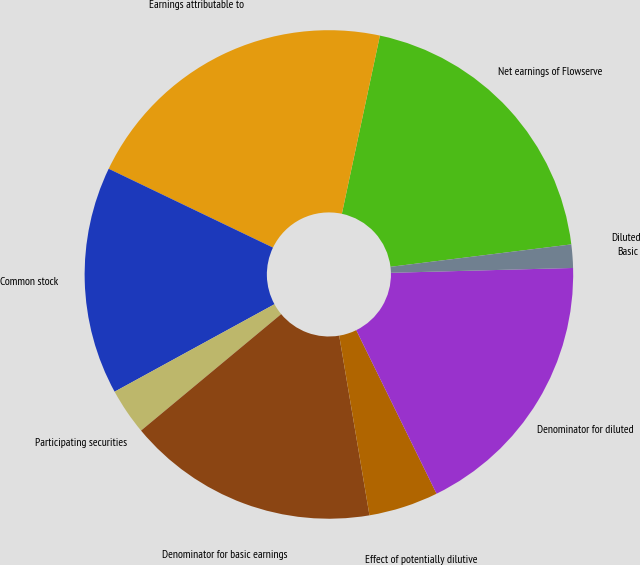Convert chart. <chart><loc_0><loc_0><loc_500><loc_500><pie_chart><fcel>Net earnings of Flowserve<fcel>Earnings attributable to<fcel>Common stock<fcel>Participating securities<fcel>Denominator for basic earnings<fcel>Effect of potentially dilutive<fcel>Denominator for diluted<fcel>Basic<fcel>Diluted<nl><fcel>19.69%<fcel>21.23%<fcel>15.09%<fcel>3.07%<fcel>16.62%<fcel>4.61%<fcel>18.16%<fcel>1.54%<fcel>0.0%<nl></chart> 